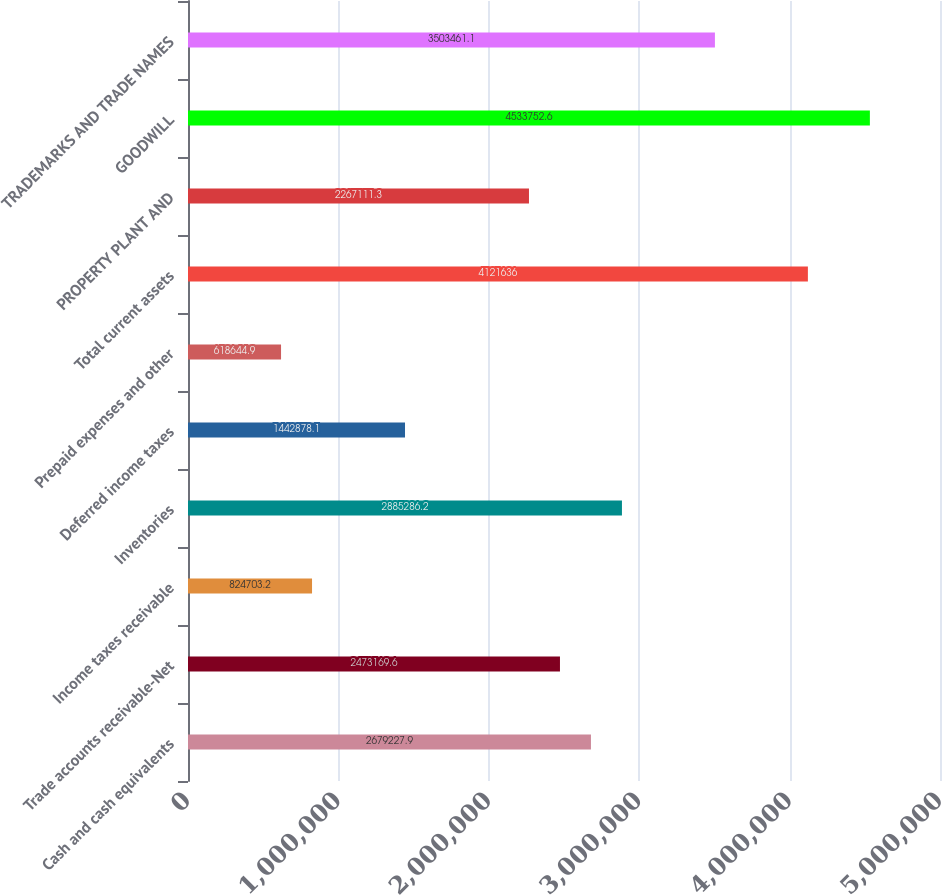Convert chart to OTSL. <chart><loc_0><loc_0><loc_500><loc_500><bar_chart><fcel>Cash and cash equivalents<fcel>Trade accounts receivable-Net<fcel>Income taxes receivable<fcel>Inventories<fcel>Deferred income taxes<fcel>Prepaid expenses and other<fcel>Total current assets<fcel>PROPERTY PLANT AND<fcel>GOODWILL<fcel>TRADEMARKS AND TRADE NAMES<nl><fcel>2.67923e+06<fcel>2.47317e+06<fcel>824703<fcel>2.88529e+06<fcel>1.44288e+06<fcel>618645<fcel>4.12164e+06<fcel>2.26711e+06<fcel>4.53375e+06<fcel>3.50346e+06<nl></chart> 